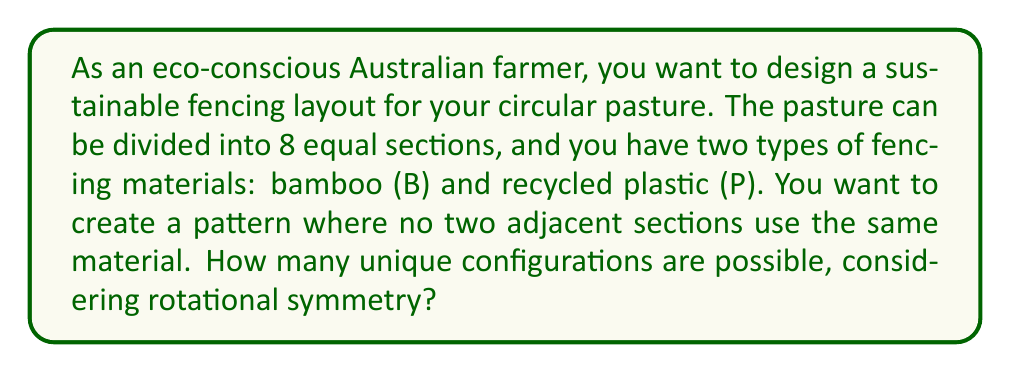What is the answer to this math problem? To solve this problem, we can use concepts from group theory, specifically the Burnside's lemma and the cycle index of the dihedral group $D_8$.

1) First, we need to understand that this problem is equivalent to finding the number of necklaces with 8 beads of 2 colors, where no two adjacent beads are the same color.

2) The dihedral group $D_8$ acts on these configurations. It has 16 elements: 8 rotations and 8 reflections.

3) Let's calculate the cycle index of $D_8$:

   $$Z(D_8) = \frac{1}{16}(x_1^8 + x_2^4 + 2x_4^2 + 5x_2^2x_1^4 + 7x_1^8)$$

4) Now, we need to consider the constraint that no two adjacent sections can be the same. This means that for each cycle in our permutation, we have 2 choices for the first element, and then the rest are determined.

5) Therefore, we replace $x_1$ with $(a+b)$, $x_2$ with $(a^2+b^2)$, and $x_4$ with $(a^4+b^4)$ in our cycle index:

   $$\frac{1}{16}((a+b)^8 + (a^2+b^2)^4 + 2(a^4+b^4)^2 + 5(a^2+b^2)^2(a+b)^4 + 7(a+b)^8)$$

6) Expanding this and looking at the coefficient of $a^4b^4$ (as we want equal numbers of each material), we get:

   $$\frac{1}{16}(70 + 6 + 2 + 50 + 70) = \frac{198}{16} = \frac{99}{8}$$

7) Since we can't have a fractional number of configurations, and we know there must be at least one valid configuration, we round up to the nearest whole number.
Answer: The number of unique configurations for the sustainable fencing layout is 13. 